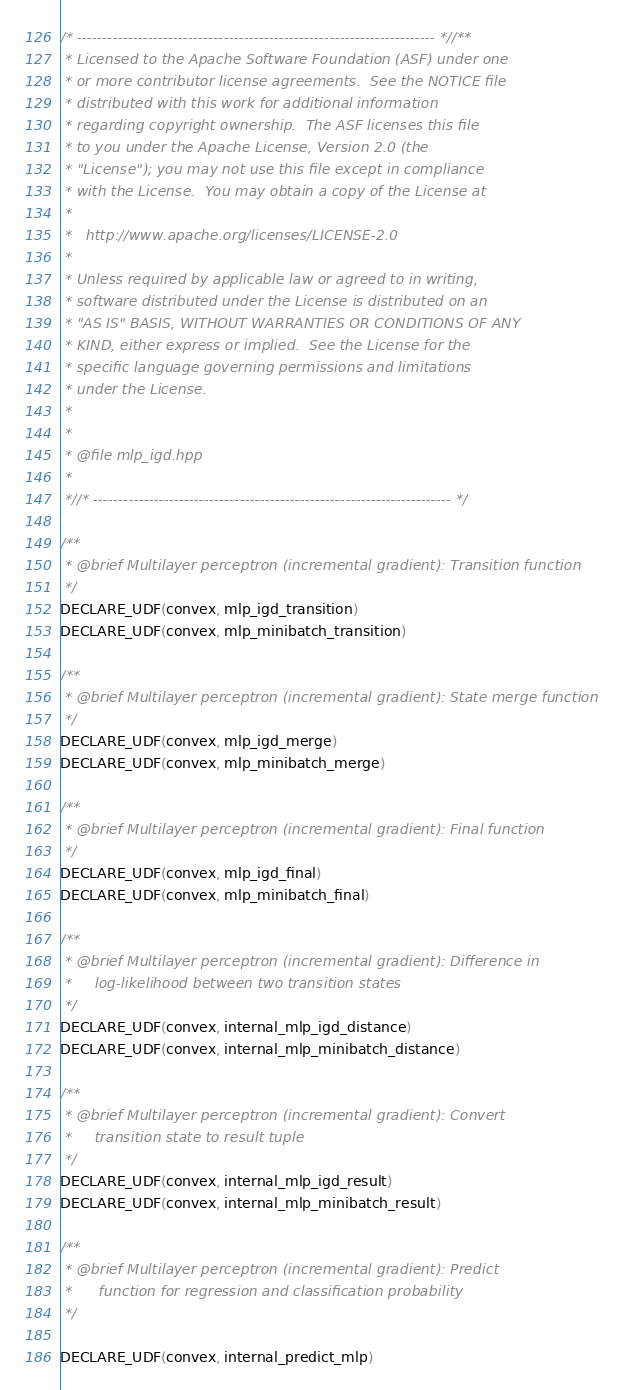Convert code to text. <code><loc_0><loc_0><loc_500><loc_500><_C++_>/* ----------------------------------------------------------------------- *//**
 * Licensed to the Apache Software Foundation (ASF) under one
 * or more contributor license agreements.  See the NOTICE file
 * distributed with this work for additional information
 * regarding copyright ownership.  The ASF licenses this file
 * to you under the Apache License, Version 2.0 (the
 * "License"); you may not use this file except in compliance
 * with the License.  You may obtain a copy of the License at
 *
 *   http://www.apache.org/licenses/LICENSE-2.0
 *
 * Unless required by applicable law or agreed to in writing,
 * software distributed under the License is distributed on an
 * "AS IS" BASIS, WITHOUT WARRANTIES OR CONDITIONS OF ANY
 * KIND, either express or implied.  See the License for the
 * specific language governing permissions and limitations
 * under the License.
 *
 *
 * @file mlp_igd.hpp
 *
 *//* ----------------------------------------------------------------------- */

/**
 * @brief Multilayer perceptron (incremental gradient): Transition function
 */
DECLARE_UDF(convex, mlp_igd_transition)
DECLARE_UDF(convex, mlp_minibatch_transition)

/**
 * @brief Multilayer perceptron (incremental gradient): State merge function
 */
DECLARE_UDF(convex, mlp_igd_merge)
DECLARE_UDF(convex, mlp_minibatch_merge)

/**
 * @brief Multilayer perceptron (incremental gradient): Final function
 */
DECLARE_UDF(convex, mlp_igd_final)
DECLARE_UDF(convex, mlp_minibatch_final)

/**
 * @brief Multilayer perceptron (incremental gradient): Difference in
 *     log-likelihood between two transition states
 */
DECLARE_UDF(convex, internal_mlp_igd_distance)
DECLARE_UDF(convex, internal_mlp_minibatch_distance)

/**
 * @brief Multilayer perceptron (incremental gradient): Convert
 *     transition state to result tuple
 */
DECLARE_UDF(convex, internal_mlp_igd_result)
DECLARE_UDF(convex, internal_mlp_minibatch_result)

/**
 * @brief Multilayer perceptron (incremental gradient): Predict
 *      function for regression and classification probability
 */

DECLARE_UDF(convex, internal_predict_mlp)
</code> 